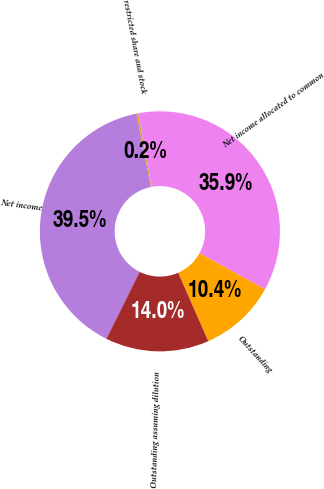Convert chart to OTSL. <chart><loc_0><loc_0><loc_500><loc_500><pie_chart><fcel>Net income<fcel>restricted share and stock<fcel>Net income allocated to common<fcel>Outstanding<fcel>Outstanding assuming dilution<nl><fcel>39.52%<fcel>0.23%<fcel>35.93%<fcel>10.37%<fcel>13.96%<nl></chart> 